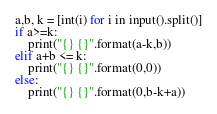<code> <loc_0><loc_0><loc_500><loc_500><_Python_>a,b, k = [int(i) for i in input().split()]
if a>=k:
    print("{} {}".format(a-k,b))
elif a+b <= k:
    print("{} {}".format(0,0))
else:
    print("{} {}".format(0,b-k+a))</code> 